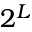Convert formula to latex. <formula><loc_0><loc_0><loc_500><loc_500>2 ^ { L }</formula> 